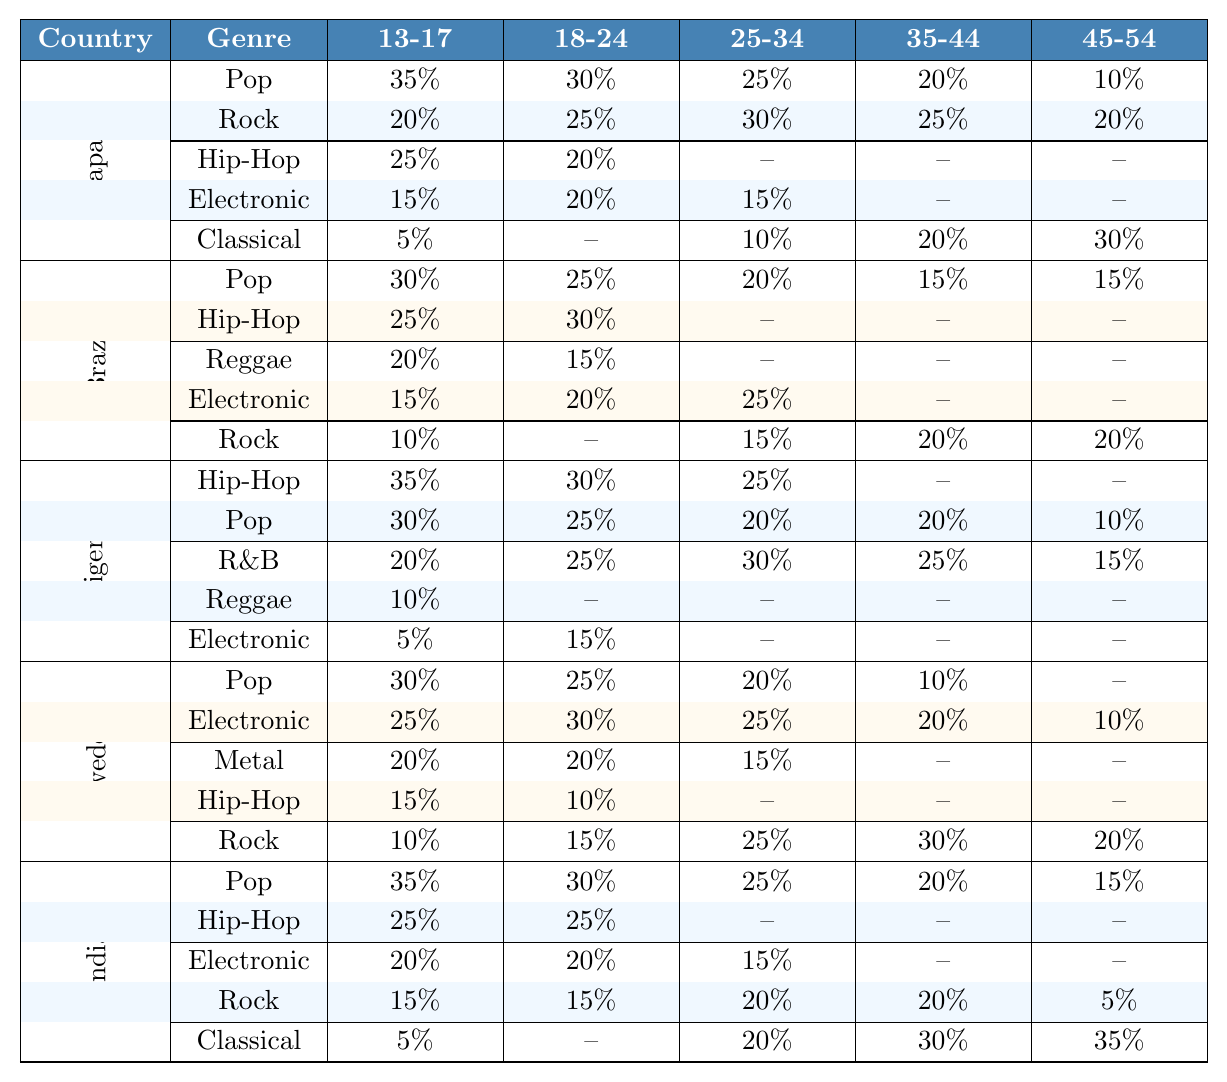What is the most popular music genre among 13-17 year-olds in Japan? The table indicates the popularity percentages for each genre among the 13-17 age group in Japan. The highest percentage is for Pop, which is 35%.
Answer: Pop Which genre has the highest percentage in the 45-54 age group in Brazil? In Brazil, the genres listed for the 45-54 age group show the highest percentage for Jazz at 30%, compared to other genres like Classical (25%), Rock (20%), etc.
Answer: Jazz Is Hip-Hop more popular than Rock among 18-24 year-olds in Nigeria? In the 18-24 age group, Hip-Hop has a percentage of 30%, while Rock has 5%. Therefore, Hip-Hop is indeed more popular than Rock in this context.
Answer: Yes What is the average percentage of Pop among all age groups in Sweden? The percentages for Pop in Sweden across all age groups are 30%, 25%, 20%, 10%, and 0%. The average is calculated as (30 + 25 + 20 + 10 + 0) / 5 = 17%.
Answer: 17% Which genre of music has the largest drop in popularity from age group 25-34 to 35-44 in Japan? For Japan, Pop drops from 25% at 25-34 to 20% at 35-44, and Rock drops from 30% to 25%. The largest drop is for Pop (5%).
Answer: Pop In which country is Electronic music consistently popular across all age groups? By looking closely at Electronic music percentages, Sweden shows a value of 25% for age groups 13-17, 30% for 18-24, 25% for 25-34, and remains present but lower in older age groups.
Answer: Sweden What is the total percentage of Jazz popularity across all age groups in India? The percentages for Jazz in India are 0% (13-17), 0% (18-24), 20% (25-34), 15% (35-44), 20% (45-54), and 15% (55+). Summing these gives 0 + 0 + 20 + 15 + 20 + 15 = 70%.
Answer: 70% Does the R&B genre have a significant presence in both Nigeria and Brazil? In Nigeria, the presence of R&B in the age groups is 20% for 13-17, 25% for 18-24, 30% for 25-34, and 25% for 35-44, while in Brazil it is only 10% in the 18-24 age group. Therefore, it is more present in Nigeria.
Answer: No What genre has the lowest percentage among the 55+ age group across all countries? Looking at the 55+ age group percentages for each country, Pop has 5% in Nigeria and India, Rock has 5% in Sweden, and so forth. However, the lowest is for Reggae, which has 0% in Nigeria and Brazil.
Answer: Reggae 